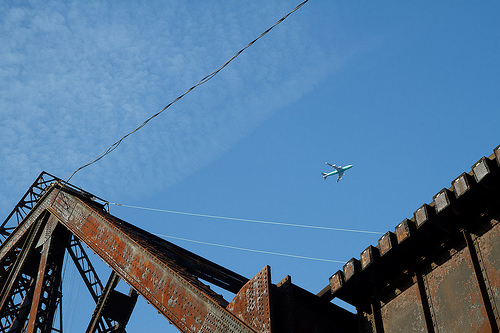Please provide a short description for this region: [0.03, 0.29, 0.27, 0.37]. A segment of the sky filled with white clouds. 